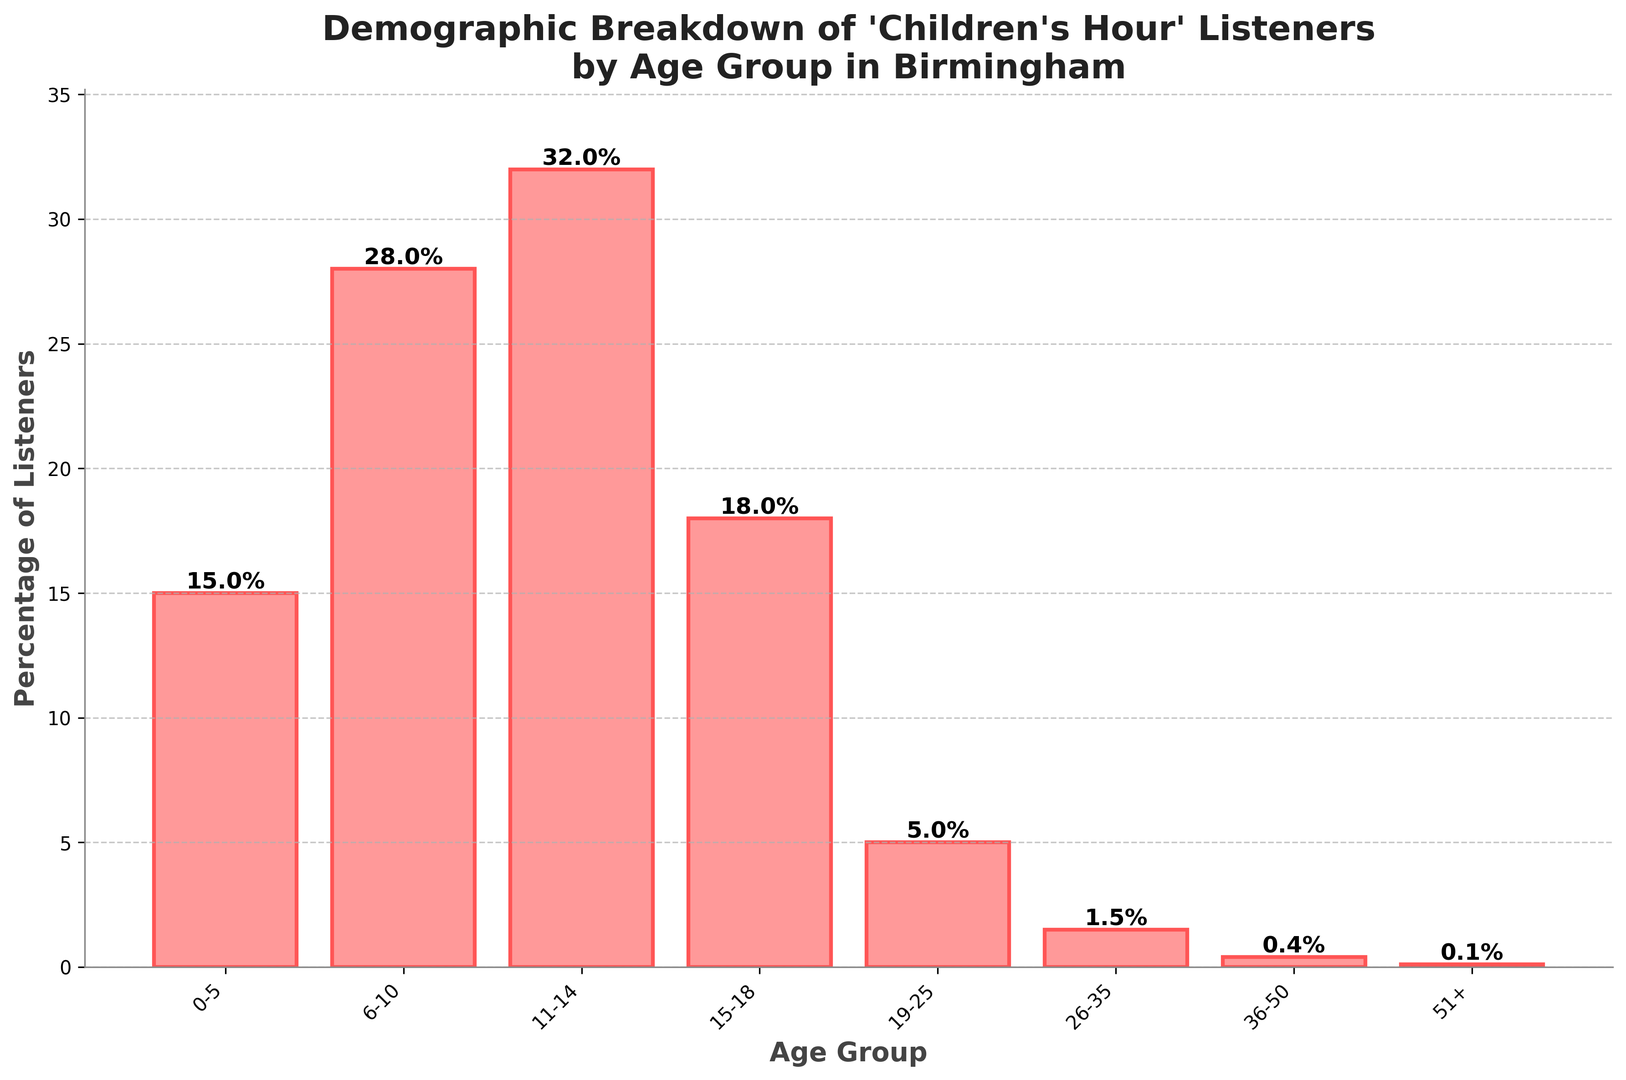Which age group has the highest percentage of listeners? The bar representing the 11-14 age group is the tallest, and the label at the top of this bar indicates it has the highest percentage.
Answer: 11-14 What is the combined percentage of listeners aged 15-18 and 19-25? The bar for the 15-18 age group shows 18%, and the bar for the 19-25 age group shows 5%. Adding these percentages gives 18% + 5% = 23%.
Answer: 23% Which age group has the lowest percentage of listeners? The bar representing the 51+ age group is the shortest, and the label at the top of this bar indicates it has the lowest percentage.
Answer: 51+ How much higher is the percentage of listeners aged 11-14 compared to 6-10? The percentage for 11-14 is 32%, and for 6-10 it is 28%. The difference is 32% - 28% = 4%.
Answer: 4% What is the total percentage of listeners aged 26-35, 36-50, and 51+? The bars show 1.5%, 0.4%, and 0.1% respectively. Adding these percentages gives 1.5% + 0.4% + 0.1% = 2%.
Answer: 2% Compare the percentage of listeners aged 0-5 to those aged 15-18. Is the percentage for the latter higher or lower? The percentage for 0-5 is 15%, and for 15-18 it is 18%. Since 18% is greater than 15%, the percentage of listeners aged 15-18 is higher.
Answer: higher By how much does the percentage of listeners in the largest group exceed the percentage in the smallest group? The largest group is 11-14 with 32%, and the smallest is 51+ with 0.1%. The difference is 32% - 0.1% = 31.9%.
Answer: 31.9% What is the difference in listener percentage between the 15-18 and 26-35 age groups? The 15-18 age group's bar shows 18%, and the 26-35 age group's bar shows 1.5%. The difference is 18% - 1.5% = 16.5%.
Answer: 16.5% What is the average percentage of listeners across all age groups? The percentages for all age groups are: 15%, 28%, 32%, 18%, 5%, 1.5%, 0.4%, and 0.1%. Adding these and dividing by the number of groups (8) gives (15 + 28 + 32 + 18 + 5 + 1.5 + 0.4 + 0.1) / 8 = 100 / 8 = 12.5%.
Answer: 12.5% 